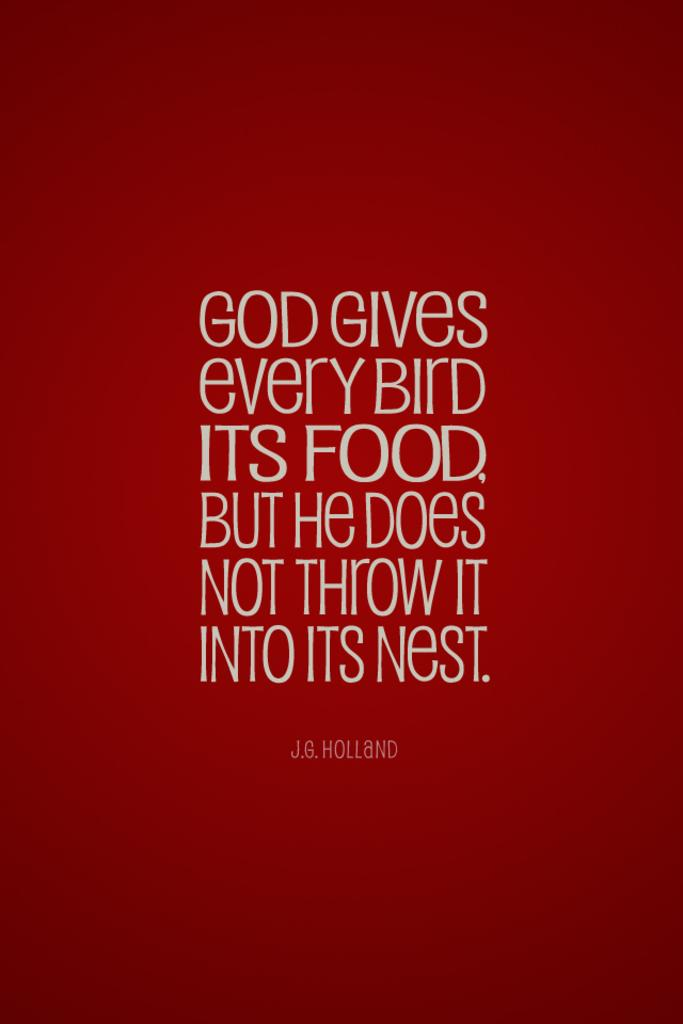<image>
Render a clear and concise summary of the photo. A red poster with God Gives every Bird ITS FOOD. But He Does Not Throw IT Into Its Nest. 